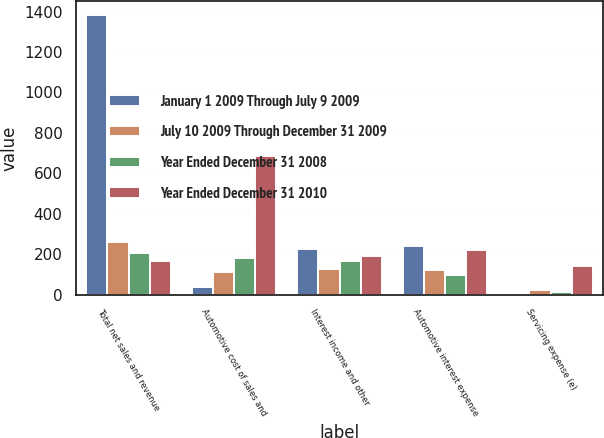Convert chart. <chart><loc_0><loc_0><loc_500><loc_500><stacked_bar_chart><ecel><fcel>Total net sales and revenue<fcel>Automotive cost of sales and<fcel>Interest income and other<fcel>Automotive interest expense<fcel>Servicing expense (e)<nl><fcel>January 1 2009 Through July 9 2009<fcel>1383<fcel>36<fcel>228<fcel>243<fcel>2<nl><fcel>July 10 2009 Through December 31 2009<fcel>259<fcel>113<fcel>127<fcel>121<fcel>22<nl><fcel>Year Ended December 31 2008<fcel>207<fcel>180<fcel>166<fcel>100<fcel>16<nl><fcel>Year Ended December 31 2010<fcel>166<fcel>688<fcel>192<fcel>221<fcel>144<nl></chart> 